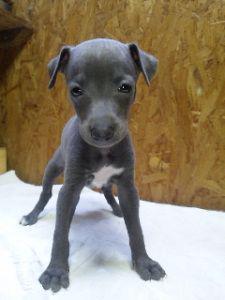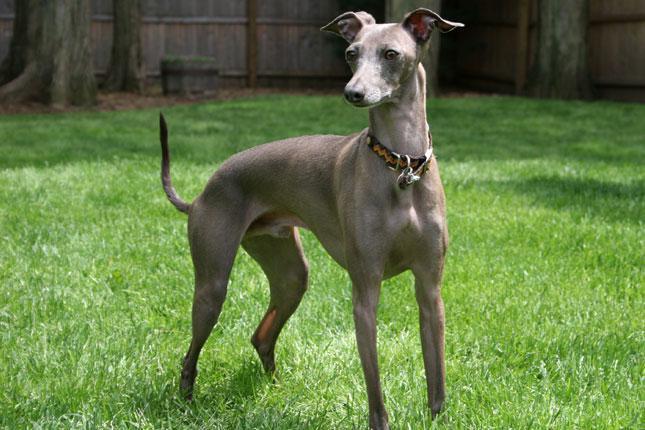The first image is the image on the left, the second image is the image on the right. For the images shown, is this caption "A person is holding the dog in the image on the left." true? Answer yes or no. No. The first image is the image on the left, the second image is the image on the right. Considering the images on both sides, is "There is at least five dogs." valid? Answer yes or no. No. 